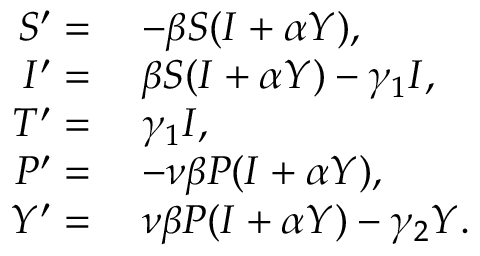Convert formula to latex. <formula><loc_0><loc_0><loc_500><loc_500>\begin{array} { r l } { S ^ { \prime } = } & { \, - \beta S ( I + \alpha Y ) , } \\ { I ^ { \prime } = } & { \, \beta S ( I + \alpha Y ) - \gamma _ { 1 } I , } \\ { T ^ { \prime } = } & { \, \gamma _ { 1 } I , } \\ { P ^ { \prime } = } & { \, - \nu \beta P ( I + \alpha Y ) , } \\ { Y ^ { \prime } = } & { \, \nu \beta P ( I + \alpha Y ) - \gamma _ { 2 } Y . } \end{array}</formula> 